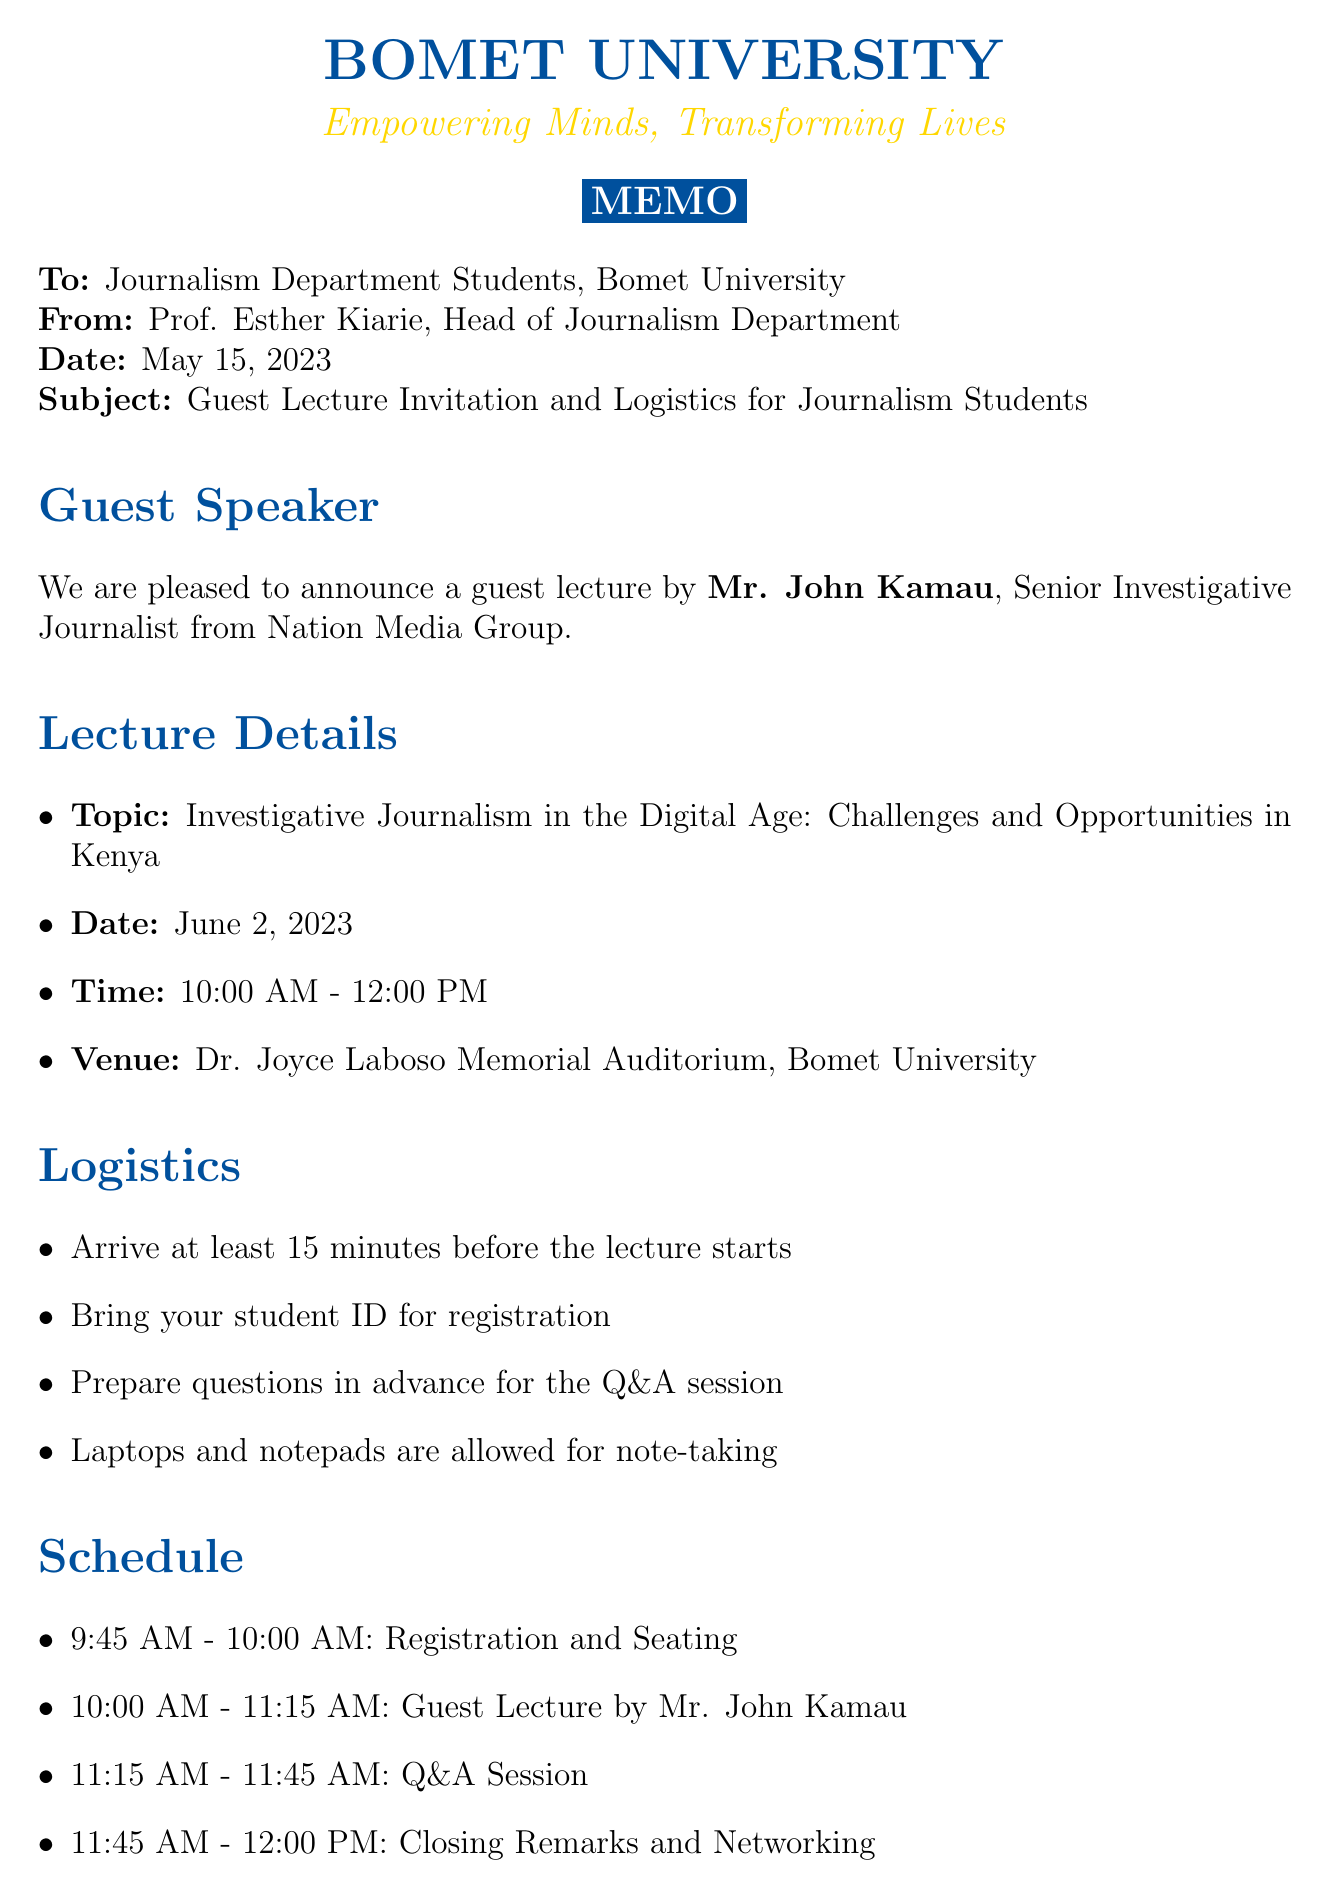What is the topic of the guest lecture? The topic is specified under the lecture details as "Investigative Journalism in the Digital Age: Challenges and Opportunities in Kenya."
Answer: Investigative Journalism in the Digital Age: Challenges and Opportunities in Kenya Who is the guest speaker? The memo indicates that the guest speaker is Mr. John Kamau.
Answer: Mr. John Kamau What organization does the guest speaker represent? The organization is mentioned as Nation Media Group in the guest speaker details.
Answer: Nation Media Group When is the guest lecture scheduled? The respective date is outlined in the lecture details as June 2, 2023.
Answer: June 2, 2023 What time does the guest lecture start? The time of the guest lecture is listed as 10:00 AM.
Answer: 10:00 AM How long will the Q&A session last? Based on the schedule, the Q&A session is from 11:15 AM to 11:45 AM, which is 30 minutes.
Answer: 30 minutes What is required for registration? The logistics section mentions the necessity of bringing a student ID for registration.
Answer: Student ID What type of students must attend the lecture? The additional information states that it is mandatory for all third and fourth-year journalism students.
Answer: Third and fourth-year journalism students What should alumni do to register for the guest lecture? The alumni registration instructions say they should email alumni@bomet.ac.ke by May 25, 2023.
Answer: Email alumni@bomet.ac.ke by May 25, 2023 Who is the contact person for this event? The contact person is specified in the document as Ms. Faith Langat.
Answer: Ms. Faith Langat 